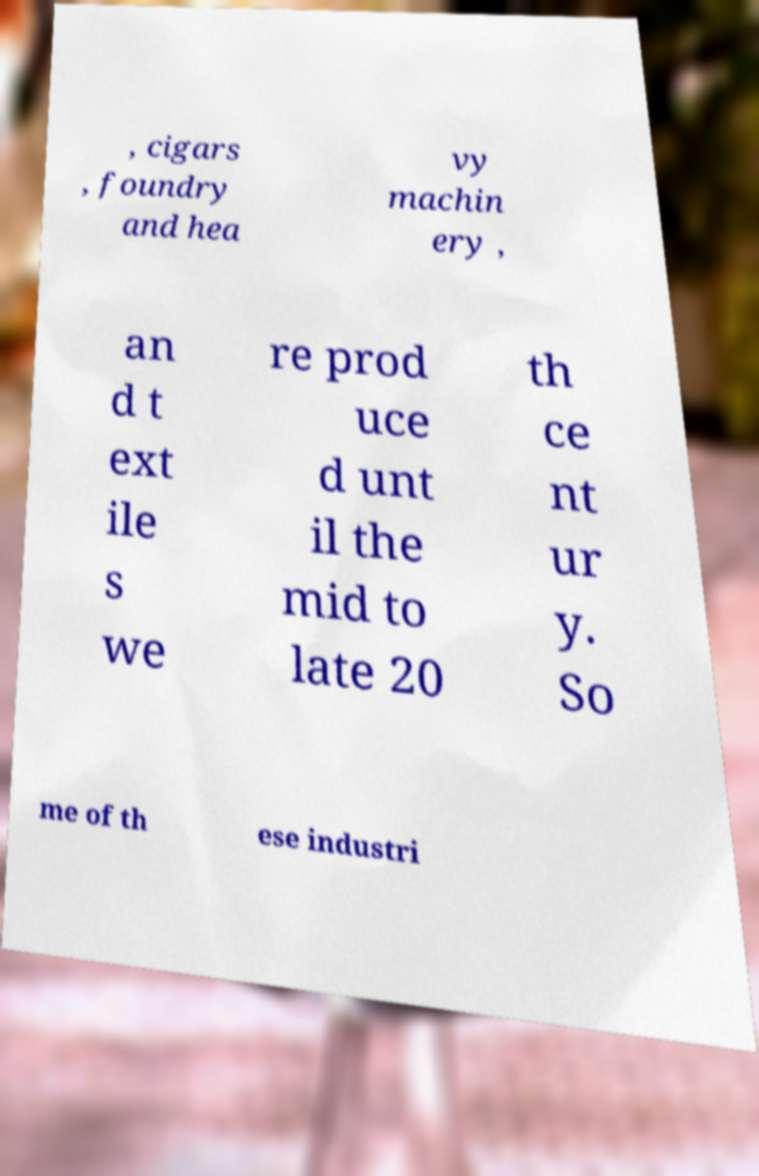Please identify and transcribe the text found in this image. , cigars , foundry and hea vy machin ery , an d t ext ile s we re prod uce d unt il the mid to late 20 th ce nt ur y. So me of th ese industri 